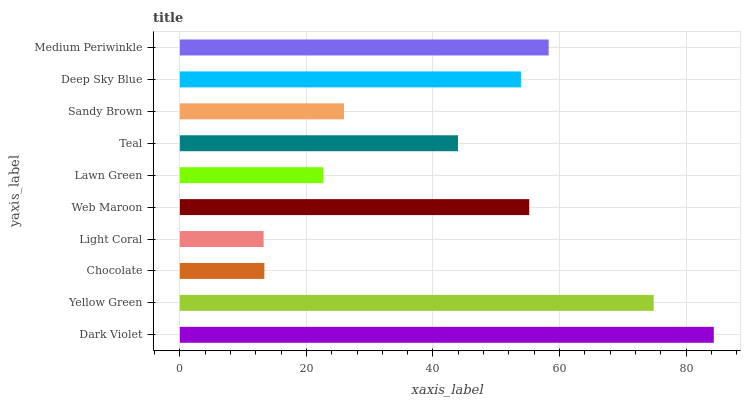Is Light Coral the minimum?
Answer yes or no. Yes. Is Dark Violet the maximum?
Answer yes or no. Yes. Is Yellow Green the minimum?
Answer yes or no. No. Is Yellow Green the maximum?
Answer yes or no. No. Is Dark Violet greater than Yellow Green?
Answer yes or no. Yes. Is Yellow Green less than Dark Violet?
Answer yes or no. Yes. Is Yellow Green greater than Dark Violet?
Answer yes or no. No. Is Dark Violet less than Yellow Green?
Answer yes or no. No. Is Deep Sky Blue the high median?
Answer yes or no. Yes. Is Teal the low median?
Answer yes or no. Yes. Is Lawn Green the high median?
Answer yes or no. No. Is Dark Violet the low median?
Answer yes or no. No. 